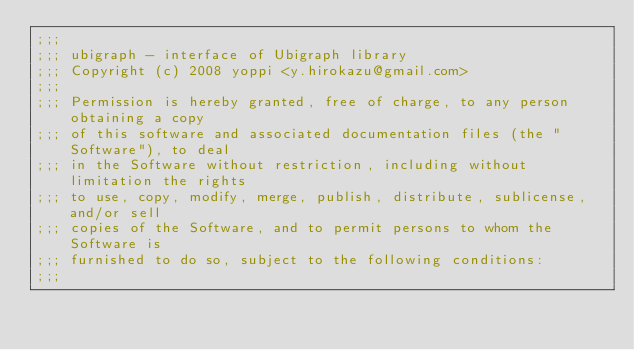Convert code to text. <code><loc_0><loc_0><loc_500><loc_500><_Scheme_>;;;
;;; ubigraph - interface of Ubigraph library
;;; Copyright (c) 2008 yoppi <y.hirokazu@gmail.com>
;;;
;;; Permission is hereby granted, free of charge, to any person obtaining a copy
;;; of this software and associated documentation files (the "Software"), to deal
;;; in the Software without restriction, including without limitation the rights
;;; to use, copy, modify, merge, publish, distribute, sublicense, and/or sell
;;; copies of the Software, and to permit persons to whom the Software is
;;; furnished to do so, subject to the following conditions:
;;;</code> 